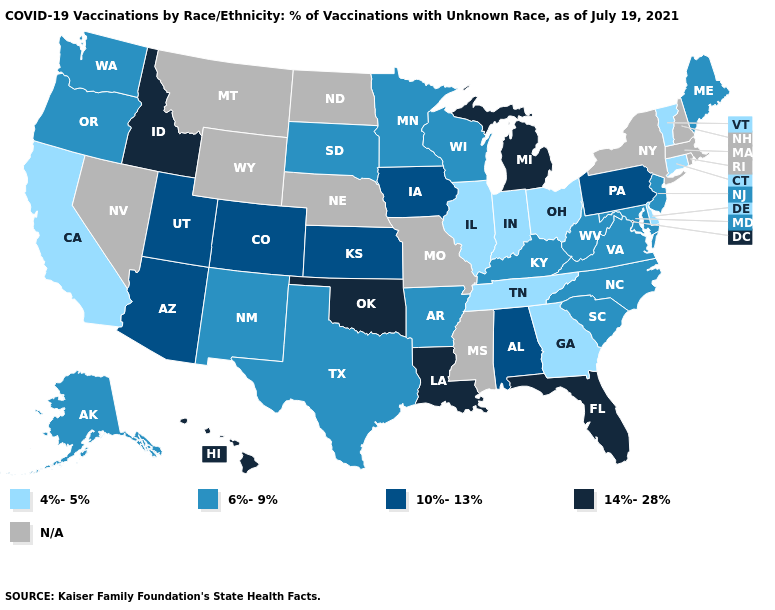What is the value of Kentucky?
Answer briefly. 6%-9%. Which states have the lowest value in the MidWest?
Answer briefly. Illinois, Indiana, Ohio. What is the value of Maine?
Keep it brief. 6%-9%. Does Kansas have the lowest value in the USA?
Concise answer only. No. What is the value of Wisconsin?
Give a very brief answer. 6%-9%. What is the value of Wisconsin?
Write a very short answer. 6%-9%. What is the value of Rhode Island?
Concise answer only. N/A. What is the value of Idaho?
Concise answer only. 14%-28%. Among the states that border New York , does Vermont have the highest value?
Concise answer only. No. Name the states that have a value in the range 4%-5%?
Write a very short answer. California, Connecticut, Delaware, Georgia, Illinois, Indiana, Ohio, Tennessee, Vermont. Name the states that have a value in the range 4%-5%?
Short answer required. California, Connecticut, Delaware, Georgia, Illinois, Indiana, Ohio, Tennessee, Vermont. What is the value of New Hampshire?
Quick response, please. N/A. Does Colorado have the highest value in the USA?
Give a very brief answer. No. What is the lowest value in the USA?
Quick response, please. 4%-5%. 